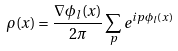Convert formula to latex. <formula><loc_0><loc_0><loc_500><loc_500>\rho ( x ) = \frac { \nabla \phi _ { l } ( x ) } { 2 \pi } \sum _ { p } e ^ { i p \phi _ { l } ( x ) }</formula> 